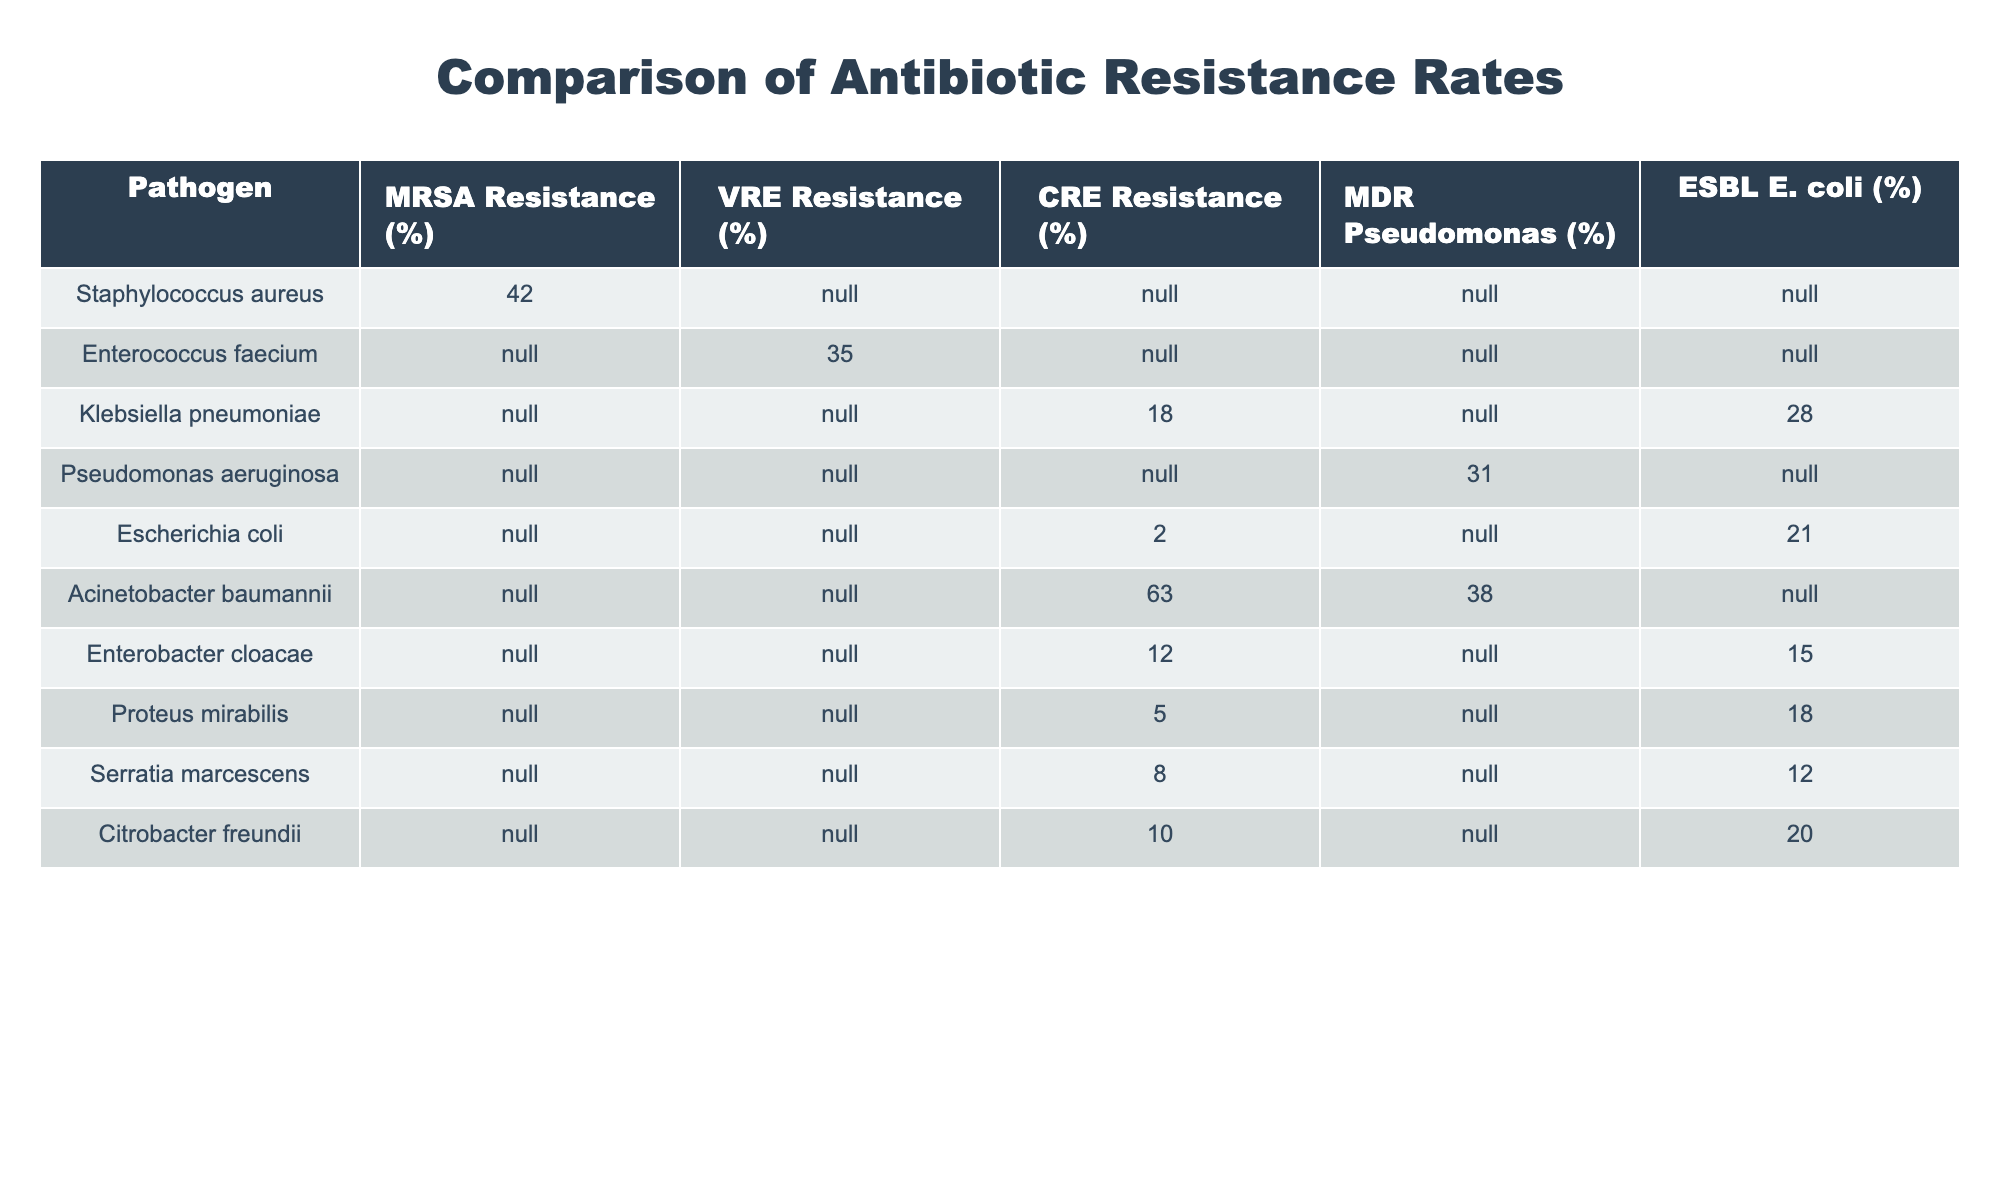What is the MRSA resistance rate for Staphylococcus aureus? The table shows that the MRSA resistance rate for Staphylococcus aureus is 42%. This value is directly stated in the respective cell of the table.
Answer: 42% Is there any Enterococcus faecium resistance data available for MDR Pseudomonas? The table indicates that there is no resistance data available for MDR Pseudomonas regarding Enterococcus faecium, as it displays 'N/A' in that cell.
Answer: No What is the highest CRE resistance percentage among the pathogens listed? From the table, Acinetobacter baumannii has the highest CRE resistance percentage at 63%. All other pathogens have lower values or 'N/A', making it the highest.
Answer: 63% What is the average ESBL E. coli resistance rate among Klebsiella pneumoniae, Enterobacter cloacae, Proteus mirabilis, and Citrobacter freundii? The resistance rates for the relevant pathogens in the table are 28% for Klebsiella pneumoniae, 15% for Enterobacter cloacae, 18% for Proteus mirabilis, and 20% for Citrobacter freundii. Adding these rates gives 28 + 15 + 18 + 20 = 81%. Since there are 4 numbers, the average is 81/4 = 20.25%. Therefore, the average ESBL E. coli resistance rate is 20.25%.
Answer: 20.25% Are all listed pathogens resistant to VRE? The table shows that only Enterococcus faecium has a VRE resistance rate of 35%, while all other pathogens have 'N/A', indicating that data is not available for them. Since not all pathogens show resistance data, the answer is no.
Answer: No Which pathogen has the second-highest rate of MDR Pseudomonas resistance? The table indicates that Pseudomonas aeruginosa has a resistance rate of 31% for MDR Pseudomonas, while Acinetobacter baumannii has a resistance rate of 38%. Thus, Pseudomonas aeruginosa is the second-highest after Acinetobacter baumannii.
Answer: Pseudomonas aeruginosa 